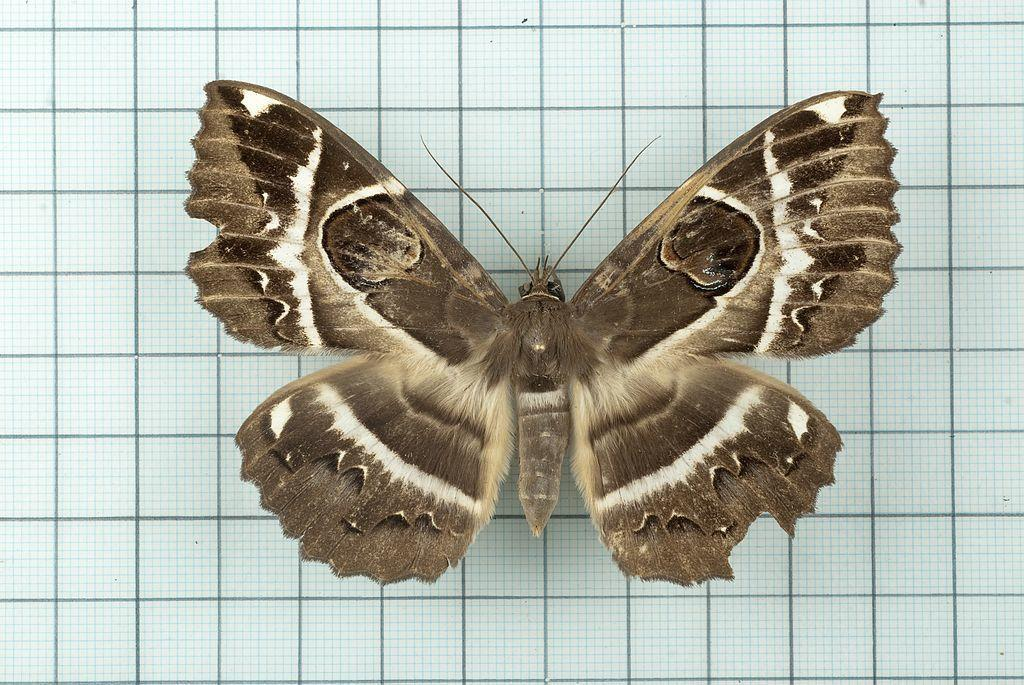What type of insect is in the picture? There is a brown butterfly in the picture. What is the color of the floor where the butterfly is sitting? The butterfly is sitting on a white floor. What colors can be seen on the butterfly's wings? The butterfly has patches of white and brown on it. What type of birds can be seen flying in the picture? There are no birds visible in the picture; it features a brown butterfly sitting on a white floor. 